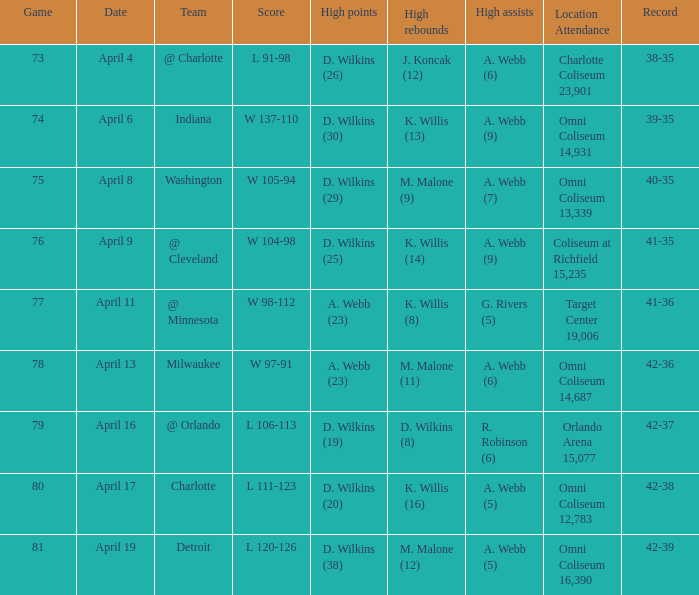What date was the game score w 104-98? April 9. 